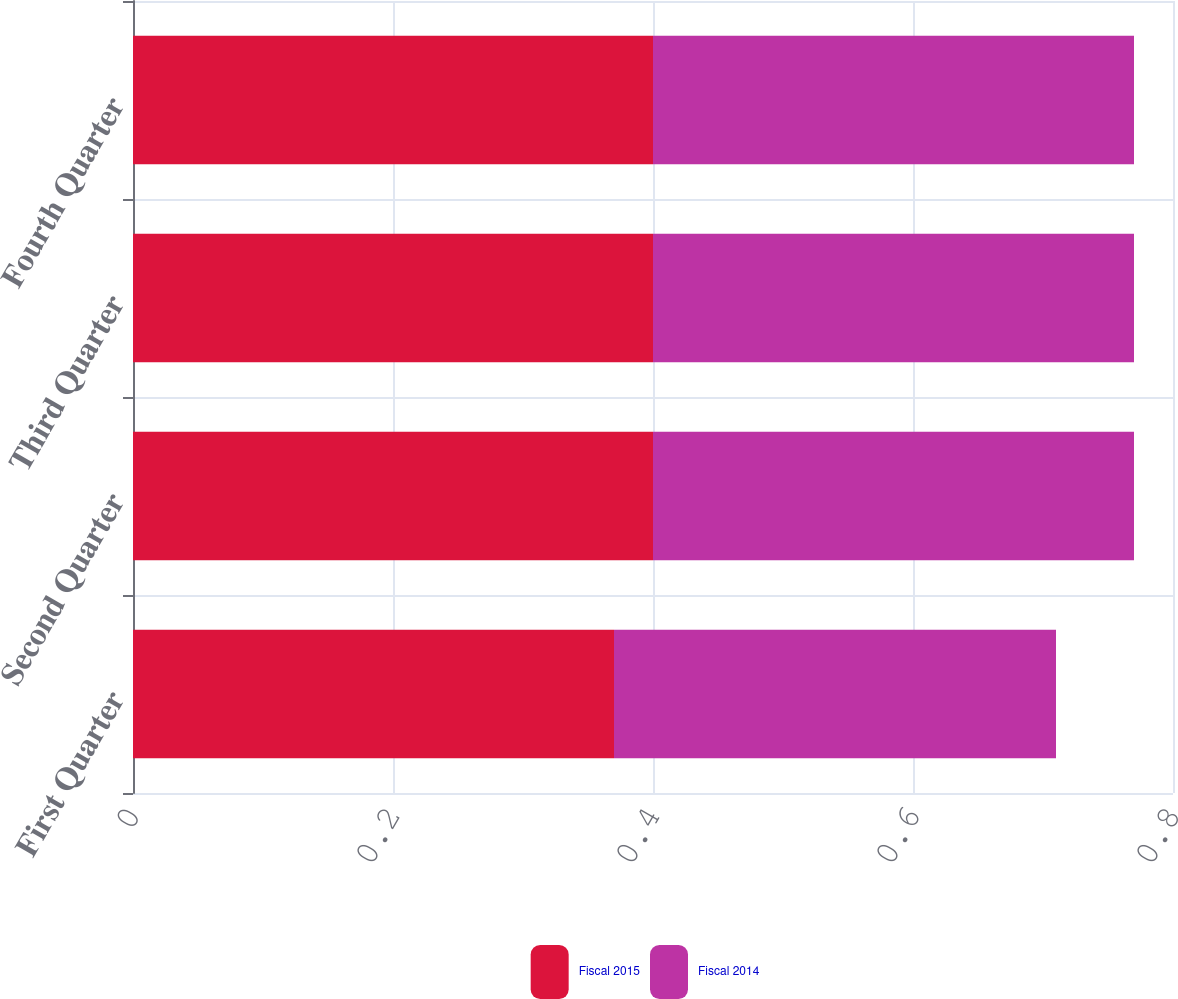Convert chart. <chart><loc_0><loc_0><loc_500><loc_500><stacked_bar_chart><ecel><fcel>First Quarter<fcel>Second Quarter<fcel>Third Quarter<fcel>Fourth Quarter<nl><fcel>Fiscal 2015<fcel>0.37<fcel>0.4<fcel>0.4<fcel>0.4<nl><fcel>Fiscal 2014<fcel>0.34<fcel>0.37<fcel>0.37<fcel>0.37<nl></chart> 